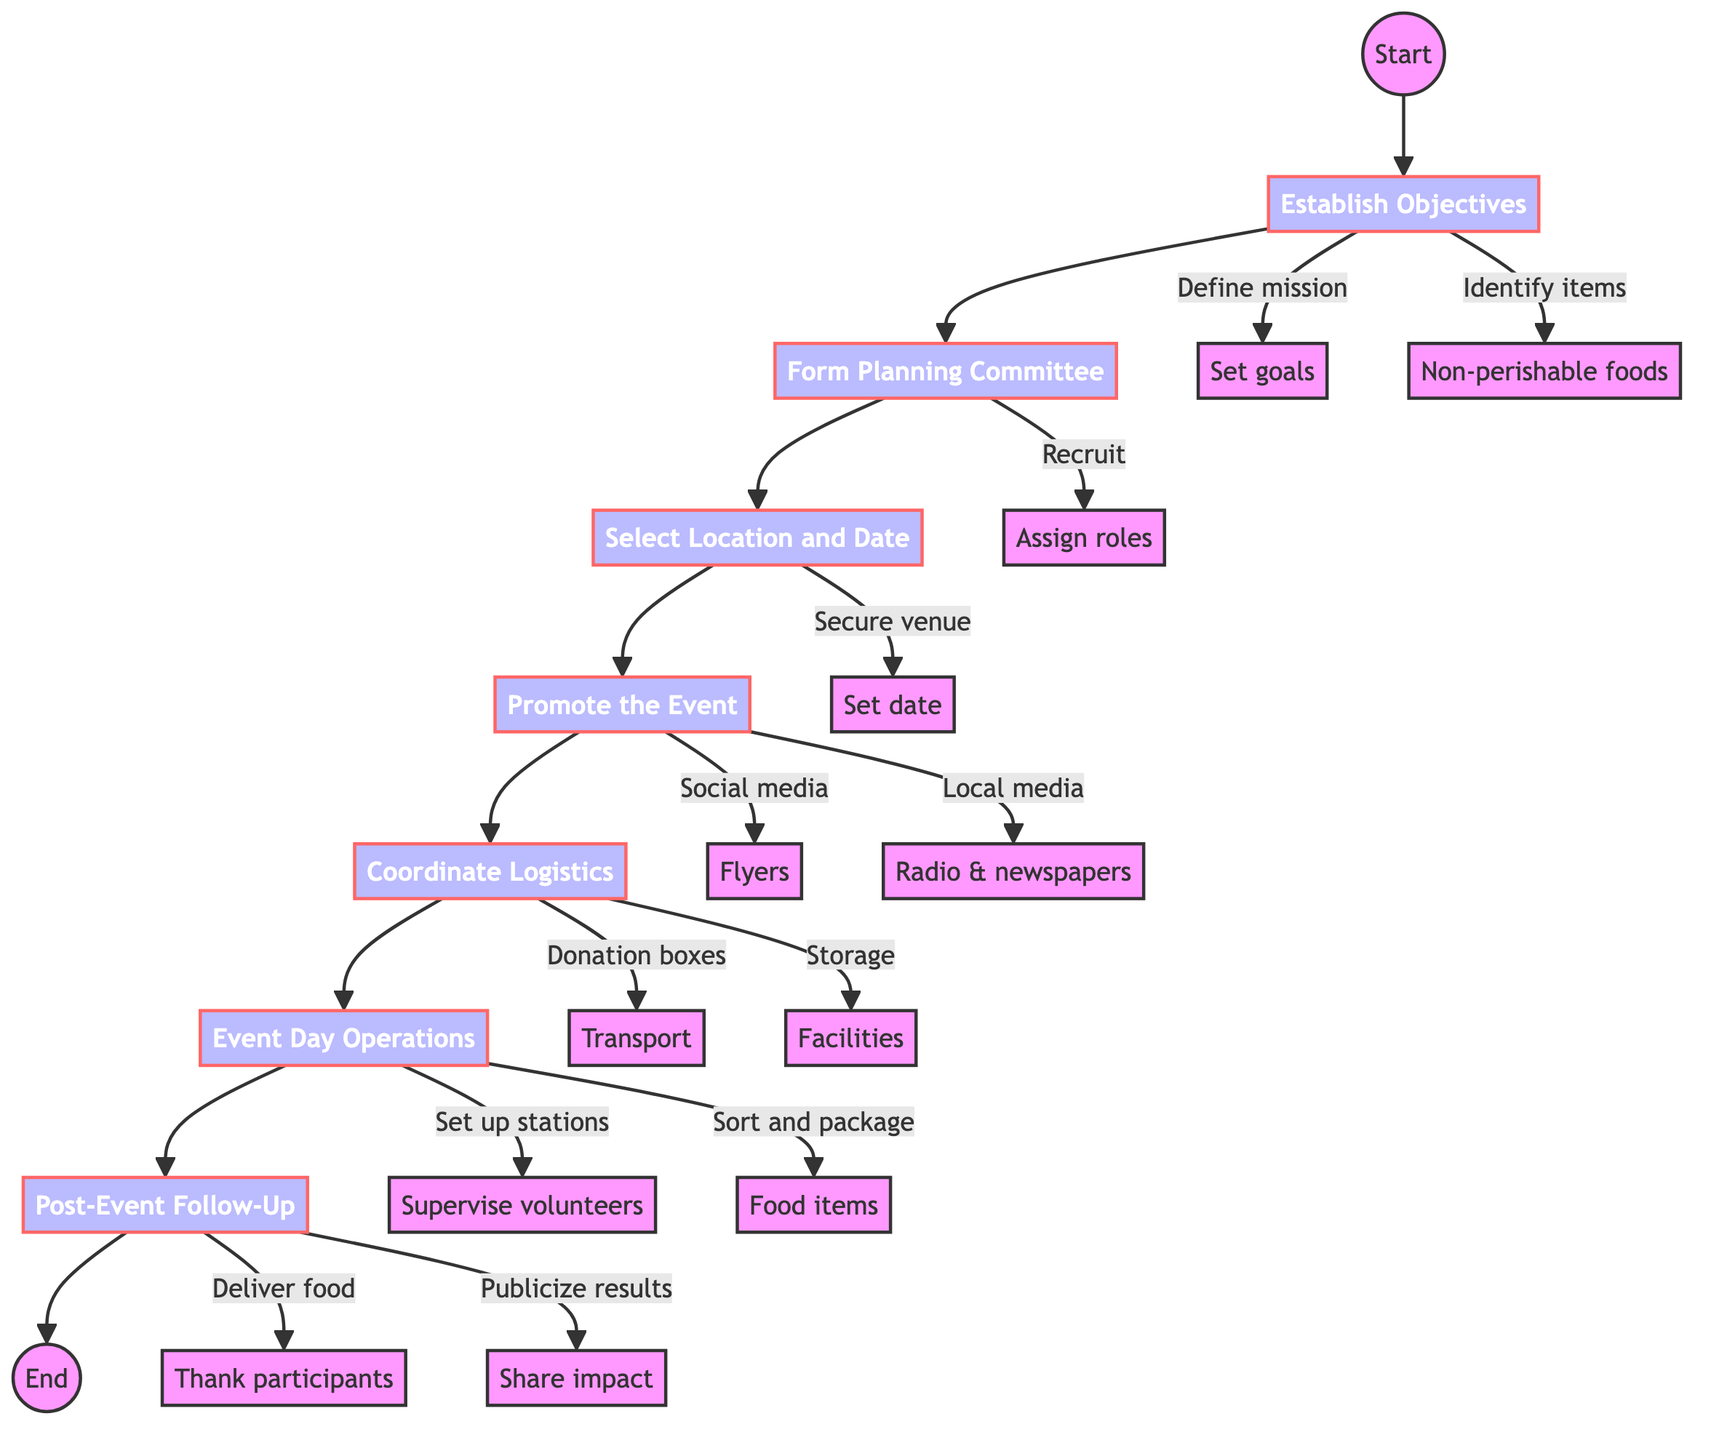What is the first step in organizing a community food drive? The first step outlined in the diagram is "Establish Objectives." It is the starting point and the first action taken to outline the goals of the food drive.
Answer: Establish Objectives How many main steps are there in the food drive process? The diagram shows a total of seven main steps, as indicated by the nodes connecting each step in the flowchart.
Answer: Seven What is one of the key actions in the 'Promote the Event' step? The 'Promote the Event' step includes several key actions, one of which is to utilize social media platforms as a means to create awareness for the event.
Answer: Utilize social media platforms What step comes after 'Select Location and Date'? Following 'Select Location and Date,' the next step in the flowchart is 'Promote the Event.' The direction of the arrows shows the sequence of the steps.
Answer: Promote the Event Which key action corresponds to collecting and sorting food items? The key actions in the 'Event Day Operations' step include "Coordinate food item sorting and packaging," which specifically pertains to the collection and organization of received items on the event day.
Answer: Coordinate food item sorting and packaging How do you ensure successful logistics for the food drive? To ensure successful logistics, the 'Coordinate Logistics' step requires collecting donation boxes and arranging transportation for the collected food items. Both actions are necessary to facilitate a smooth operation.
Answer: Collect donation boxes and transport Which step involves thanking volunteers and participants? 'Post-Event Follow-Up' is the step that includes the key action of thanking volunteers and participants as part of concluding the food drive and showing appreciation for their contributions.
Answer: Post-Event Follow-Up What is the last step of the food drive process? The last step in the process, as indicated by the flowchart, is 'Post-Event Follow-Up,' which signifies the conclusion of the organized food drive efforts.
Answer: Post-Event Follow-Up What is required after 'Event Day Operations' before concluding the food drive? After 'Event Day Operations,' the next required action is the 'Post-Event Follow-Up,' which is essential for delivering food items and publicizing results before concluding the food drive.
Answer: Post-Event Follow-Up 